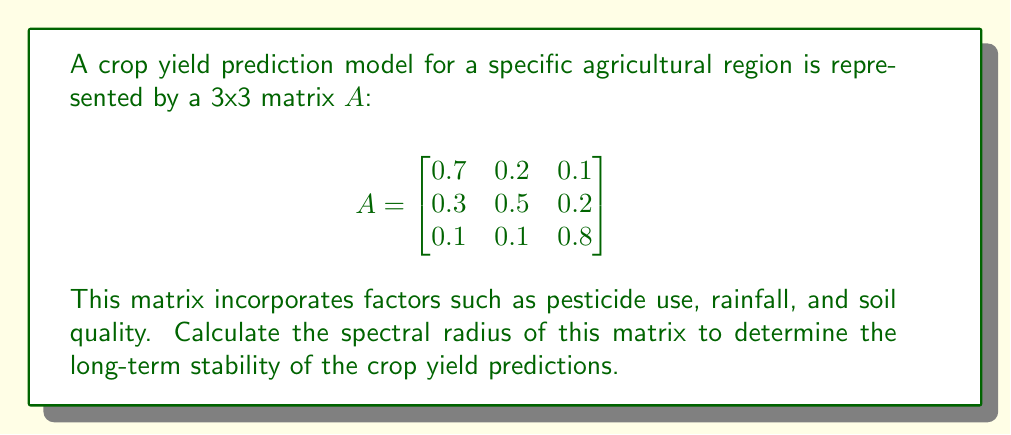Give your solution to this math problem. To find the spectral radius of matrix $A$, we need to follow these steps:

1) First, calculate the characteristic polynomial of $A$:
   $det(A - \lambda I) = 0$

   $$\begin{vmatrix}
   0.7-\lambda & 0.2 & 0.1 \\
   0.3 & 0.5-\lambda & 0.2 \\
   0.1 & 0.1 & 0.8-\lambda
   \end{vmatrix} = 0$$

2) Expand the determinant:
   $(0.7-\lambda)[(0.5-\lambda)(0.8-\lambda)-0.02] - 0.2[0.3(0.8-\lambda)-0.02] + 0.1[0.3(0.1)-0.1(0.5-\lambda)] = 0$

3) Simplify:
   $-\lambda^3 + 2\lambda^2 - 1.3\lambda + 0.28 = 0$

4) Solve this cubic equation. The roots are the eigenvalues of $A$. Using a numerical method or computer algebra system, we find:
   $\lambda_1 \approx 1.0295$
   $\lambda_2 \approx 0.5352$
   $\lambda_3 \approx 0.4353$

5) The spectral radius $\rho(A)$ is the maximum of the absolute values of these eigenvalues:

   $\rho(A) = \max(|\lambda_1|, |\lambda_2|, |\lambda_3|) = |\lambda_1| \approx 1.0295$
Answer: $\rho(A) \approx 1.0295$ 